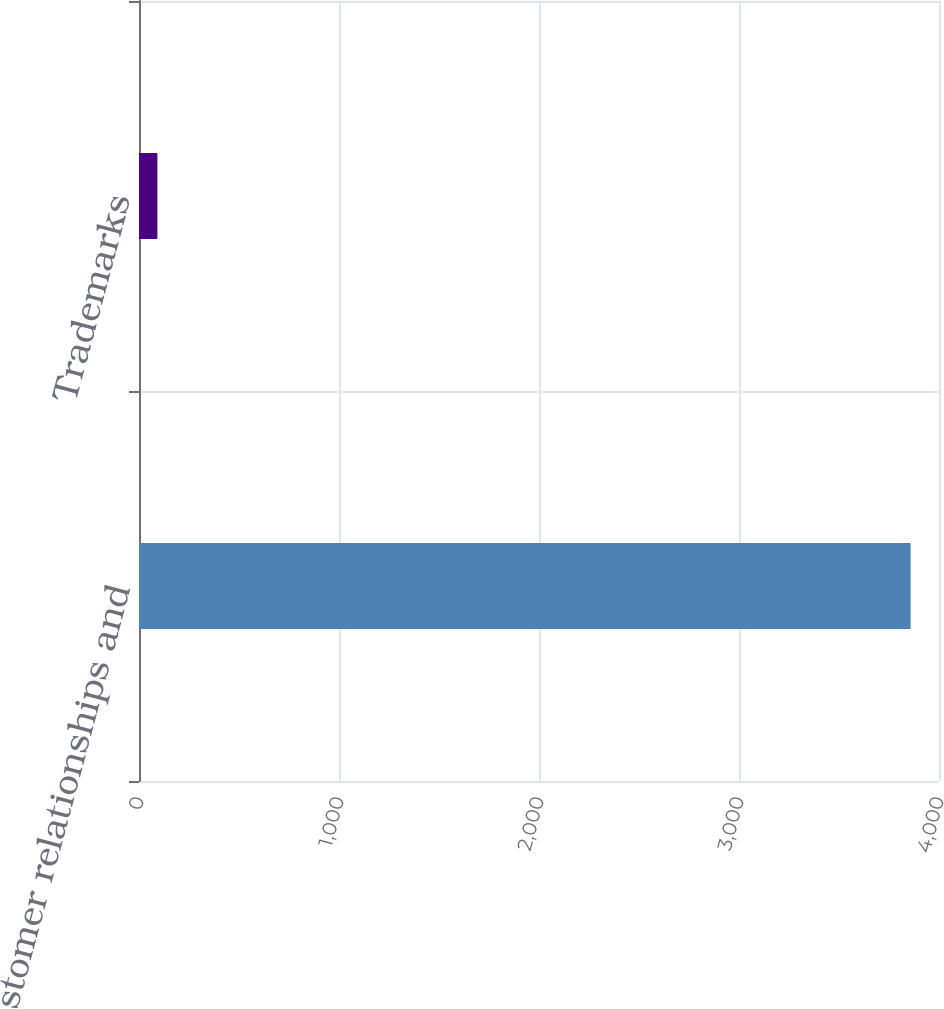Convert chart to OTSL. <chart><loc_0><loc_0><loc_500><loc_500><bar_chart><fcel>Customer relationships and<fcel>Trademarks<nl><fcel>3858<fcel>92<nl></chart> 